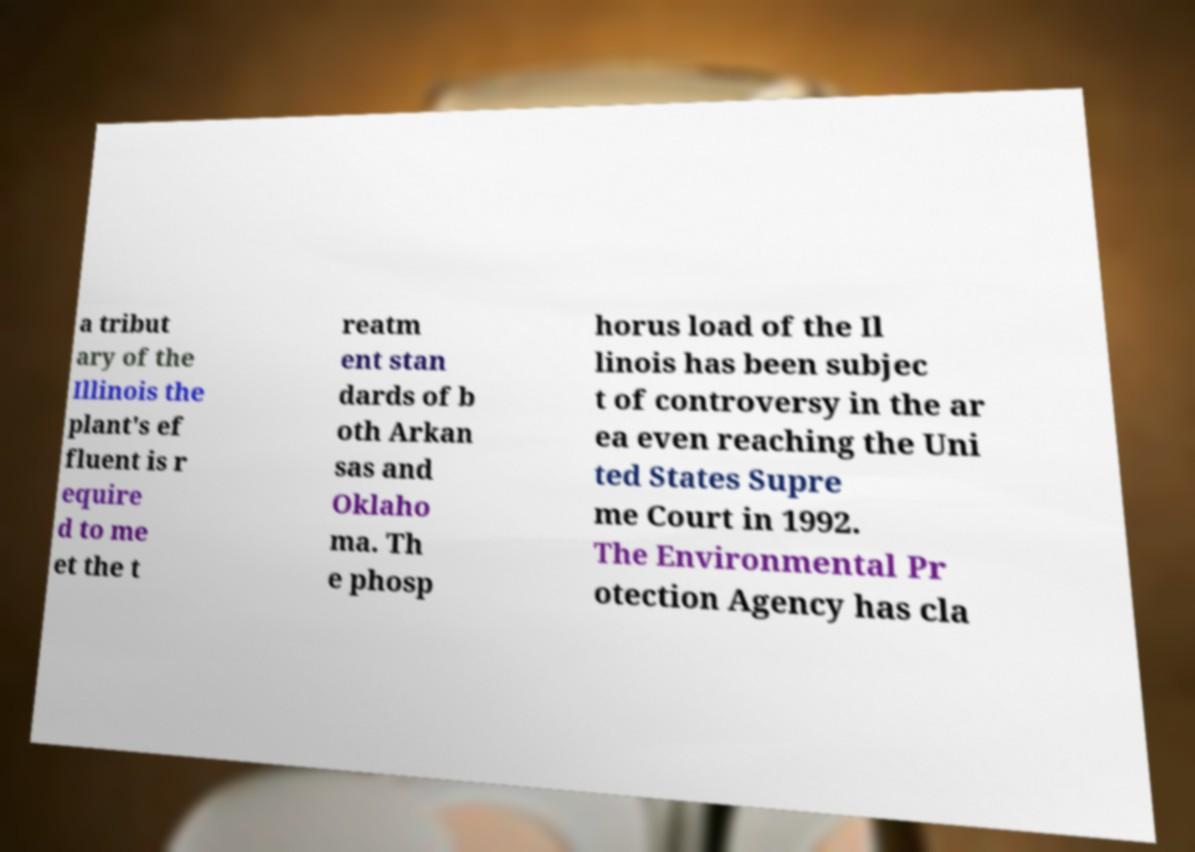I need the written content from this picture converted into text. Can you do that? a tribut ary of the Illinois the plant's ef fluent is r equire d to me et the t reatm ent stan dards of b oth Arkan sas and Oklaho ma. Th e phosp horus load of the Il linois has been subjec t of controversy in the ar ea even reaching the Uni ted States Supre me Court in 1992. The Environmental Pr otection Agency has cla 